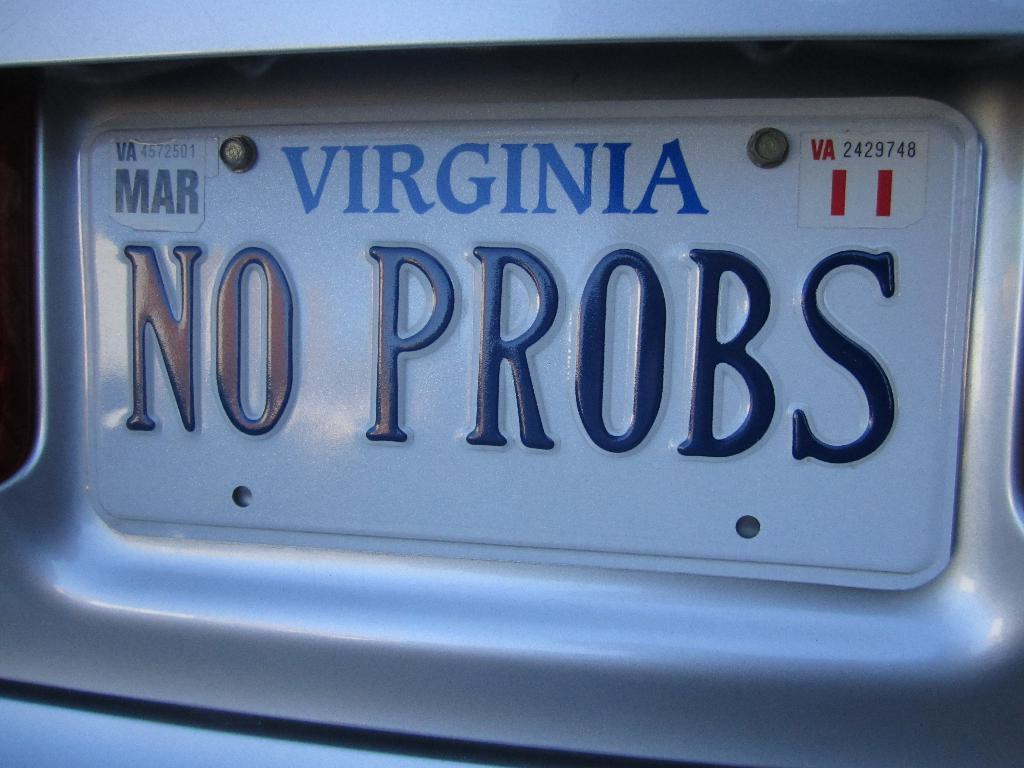<image>
Render a clear and concise summary of the photo. A State of Virginia license plate which has a March renewal tag. 